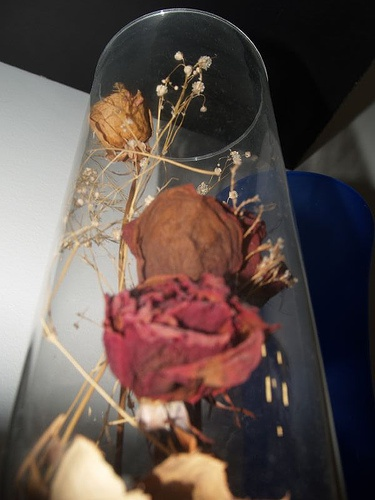Describe the objects in this image and their specific colors. I can see a vase in black, brown, gray, and darkgray tones in this image. 